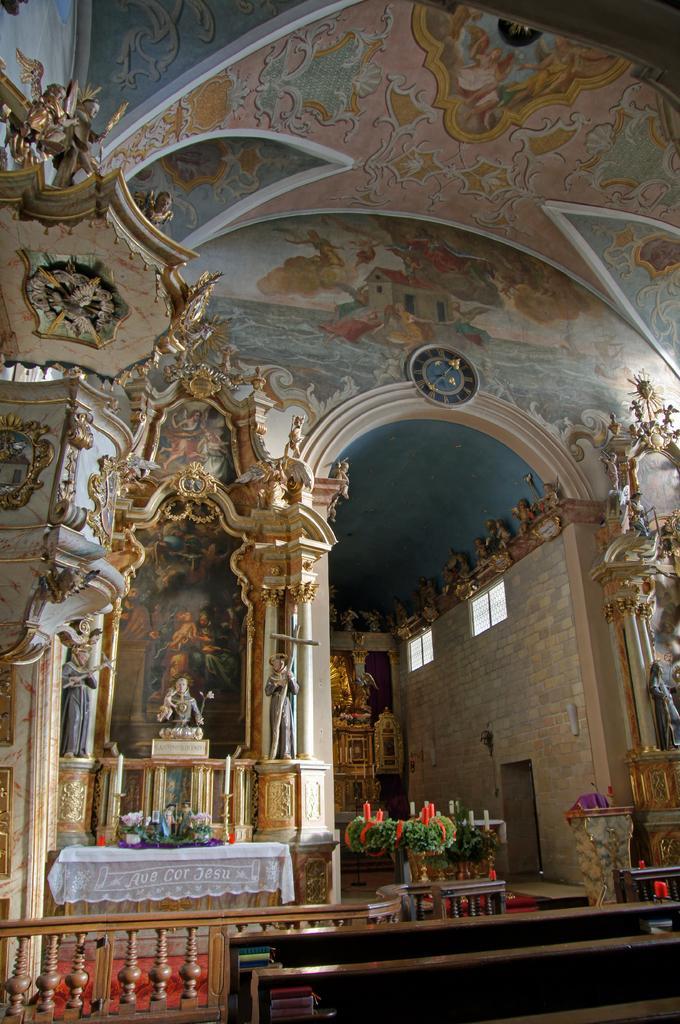How would you summarize this image in a sentence or two? In this picture we can see there are balusters, cloth, decorative plants and sculptures. At the top, there are paintings on the ceiling. 